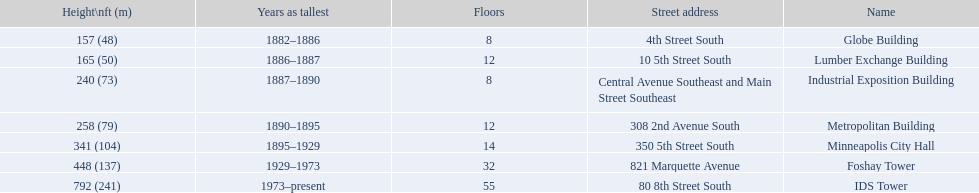Is the metropolitan building or the lumber exchange building taller? Metropolitan Building. 